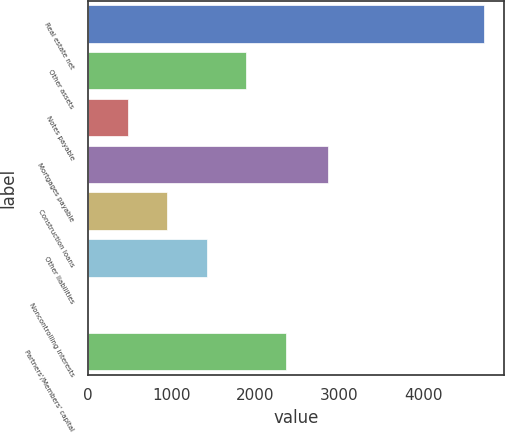Convert chart. <chart><loc_0><loc_0><loc_500><loc_500><bar_chart><fcel>Real estate net<fcel>Other assets<fcel>Notes payable<fcel>Mortgages payable<fcel>Construction loans<fcel>Other liabilities<fcel>Noncontrolling interests<fcel>Partners'/Members' capital<nl><fcel>4725.2<fcel>1891.04<fcel>473.96<fcel>2862.6<fcel>946.32<fcel>1418.68<fcel>1.6<fcel>2363.4<nl></chart> 